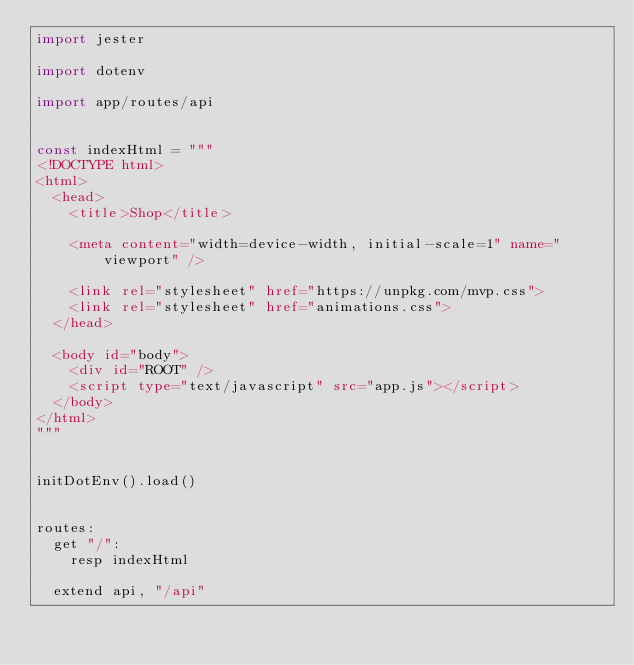<code> <loc_0><loc_0><loc_500><loc_500><_Nim_>import jester

import dotenv

import app/routes/api


const indexHtml = """
<!DOCTYPE html>
<html>
  <head>
    <title>Shop</title>

    <meta content="width=device-width, initial-scale=1" name="viewport" />

    <link rel="stylesheet" href="https://unpkg.com/mvp.css">
    <link rel="stylesheet" href="animations.css">
  </head>

  <body id="body">
    <div id="ROOT" />
    <script type="text/javascript" src="app.js"></script>
  </body>
</html>
"""


initDotEnv().load()


routes:
  get "/":
    resp indexHtml

  extend api, "/api"
</code> 